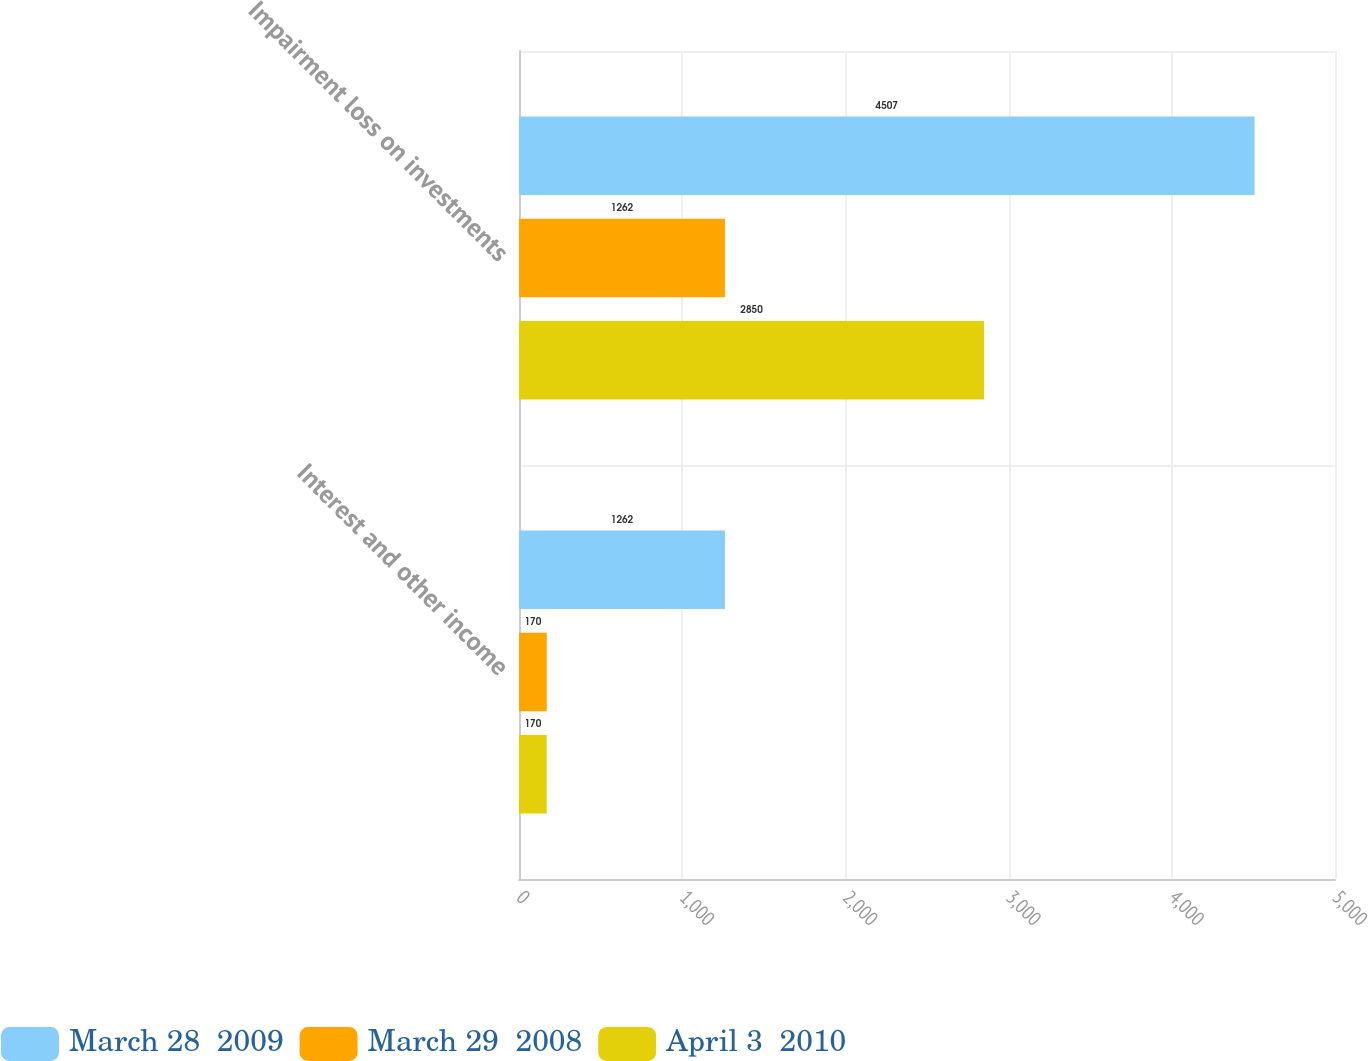<chart> <loc_0><loc_0><loc_500><loc_500><stacked_bar_chart><ecel><fcel>Interest and other income<fcel>Impairment loss on investments<nl><fcel>March 28  2009<fcel>1262<fcel>4507<nl><fcel>March 29  2008<fcel>170<fcel>1262<nl><fcel>April 3  2010<fcel>170<fcel>2850<nl></chart> 